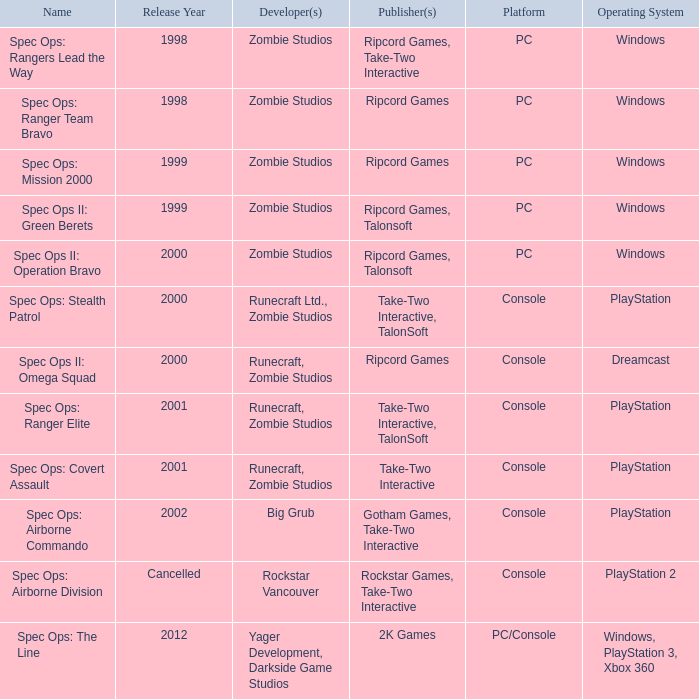Which publisher has release year of 2000 and an original dreamcast platform? Ripcord Games. 